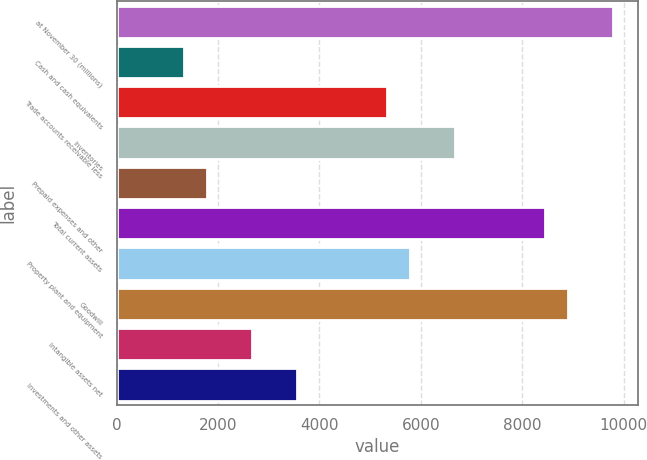Convert chart. <chart><loc_0><loc_0><loc_500><loc_500><bar_chart><fcel>at November 30 (millions)<fcel>Cash and cash equivalents<fcel>Trade accounts receivable less<fcel>Inventories<fcel>Prepaid expenses and other<fcel>Total current assets<fcel>Property plant and equipment<fcel>Goodwill<fcel>Intangible assets net<fcel>Investments and other assets<nl><fcel>9788.98<fcel>1335.12<fcel>5339.58<fcel>6674.4<fcel>1780.06<fcel>8454.16<fcel>5784.52<fcel>8899.1<fcel>2669.94<fcel>3559.82<nl></chart> 